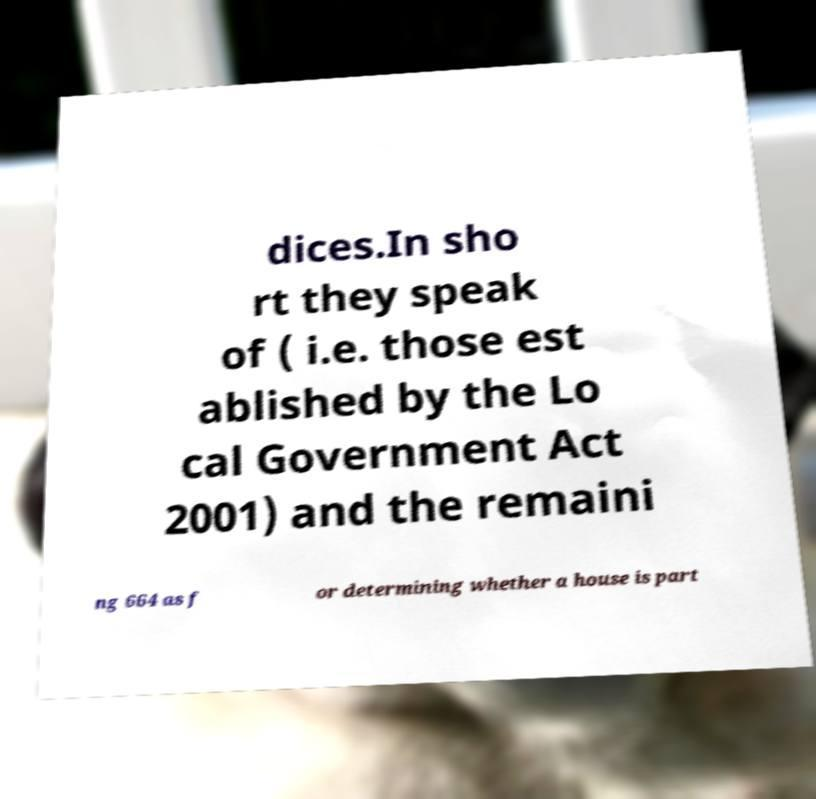What messages or text are displayed in this image? I need them in a readable, typed format. dices.In sho rt they speak of ( i.e. those est ablished by the Lo cal Government Act 2001) and the remaini ng 664 as f or determining whether a house is part 